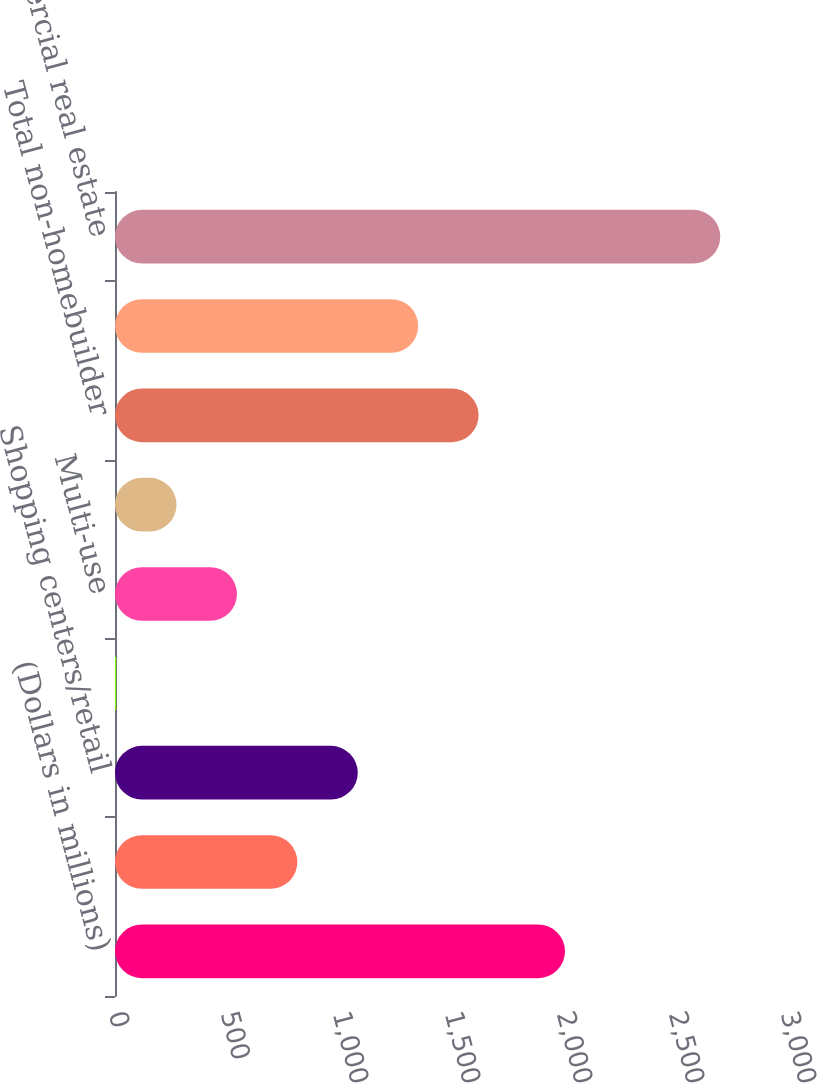Convert chart to OTSL. <chart><loc_0><loc_0><loc_500><loc_500><bar_chart><fcel>(Dollars in millions)<fcel>Multi-family rental<fcel>Shopping centers/retail<fcel>Hotels/motels<fcel>Multi-use<fcel>Other (4)<fcel>Total non-homebuilder<fcel>Commercial real estate -<fcel>Total commercial real estate<nl><fcel>2009<fcel>814.1<fcel>1083.8<fcel>5<fcel>544.4<fcel>274.7<fcel>1623.2<fcel>1353.5<fcel>2702<nl></chart> 